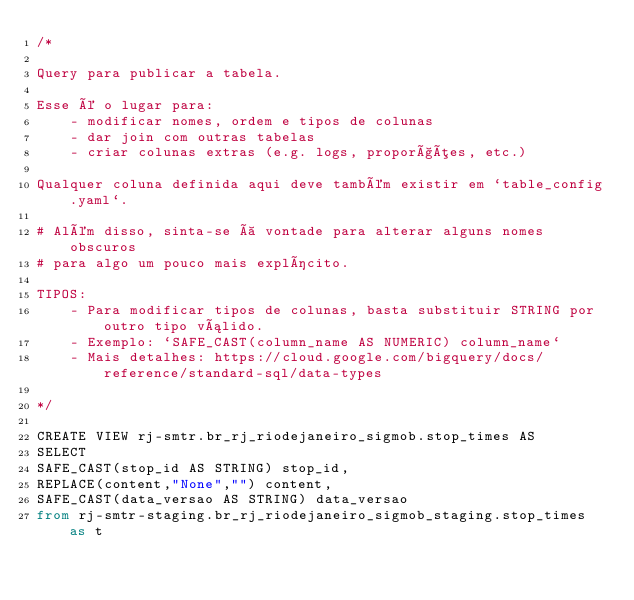<code> <loc_0><loc_0><loc_500><loc_500><_SQL_>/*

Query para publicar a tabela.

Esse é o lugar para:
    - modificar nomes, ordem e tipos de colunas
    - dar join com outras tabelas
    - criar colunas extras (e.g. logs, proporções, etc.)

Qualquer coluna definida aqui deve também existir em `table_config.yaml`.

# Além disso, sinta-se à vontade para alterar alguns nomes obscuros
# para algo um pouco mais explícito.

TIPOS:
    - Para modificar tipos de colunas, basta substituir STRING por outro tipo válido.
    - Exemplo: `SAFE_CAST(column_name AS NUMERIC) column_name`
    - Mais detalhes: https://cloud.google.com/bigquery/docs/reference/standard-sql/data-types

*/

CREATE VIEW rj-smtr.br_rj_riodejaneiro_sigmob.stop_times AS
SELECT 
SAFE_CAST(stop_id AS STRING) stop_id,
REPLACE(content,"None","") content,
SAFE_CAST(data_versao AS STRING) data_versao
from rj-smtr-staging.br_rj_riodejaneiro_sigmob_staging.stop_times as t</code> 